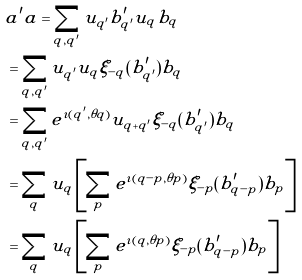Convert formula to latex. <formula><loc_0><loc_0><loc_500><loc_500>& a ^ { \prime } a = \sum _ { q , q ^ { \prime } } u _ { q ^ { \prime } } b ^ { \prime } _ { q ^ { \prime } } u _ { q } b _ { q } \\ & = \sum _ { q , q ^ { \prime } } u _ { q ^ { \prime } } u _ { q } \xi _ { - q } ( b ^ { \prime } _ { q ^ { \prime } } ) b _ { q } \\ & = \sum _ { q , q ^ { \prime } } e ^ { \imath ( q ^ { \prime } , \theta q ) } u _ { q + q ^ { \prime } } \xi _ { - q } ( b ^ { \prime } _ { q ^ { \prime } } ) b _ { q } \\ & = \sum _ { q } u _ { q } \left [ \sum _ { p } e ^ { \imath ( q - p , \theta p ) } \xi _ { - p } ( b ^ { \prime } _ { q - p } ) b _ { p } \right ] \\ & = \sum _ { q } u _ { q } \left [ \sum _ { p } e ^ { \imath ( q , \theta p ) } \xi _ { - p } ( b ^ { \prime } _ { q - p } ) b _ { p } \right ]</formula> 